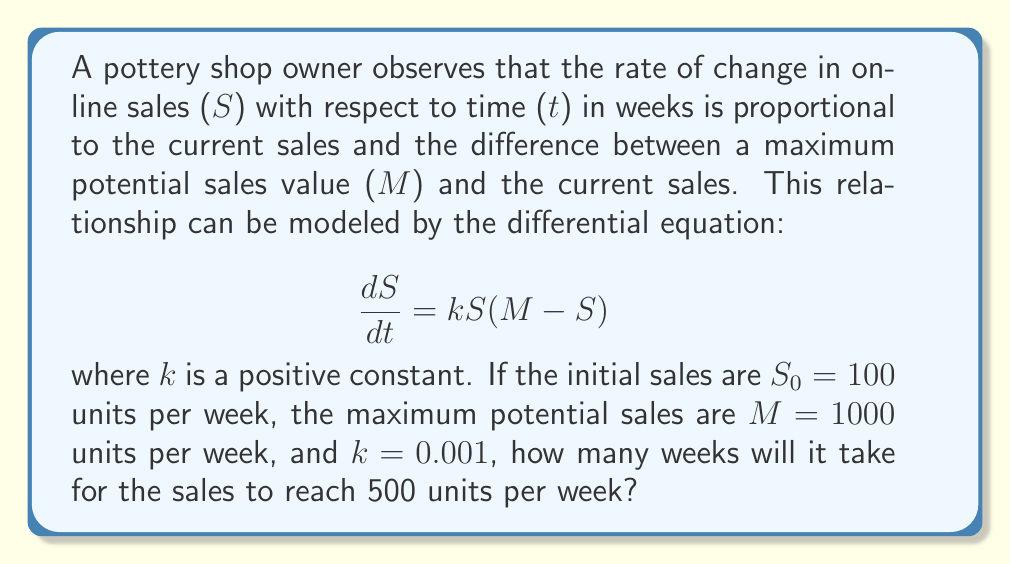Give your solution to this math problem. To solve this problem, we need to use the logistic growth model and its solution. The steps are as follows:

1) The given differential equation is a logistic growth model:

   $$\frac{dS}{dt} = kS(M-S)$$

2) The solution to this equation is:

   $$S(t) = \frac{M}{1 + (\frac{M}{S_0} - 1)e^{-kMt}}$$

3) We're given the following values:
   $S_0 = 100$, $M = 1000$, $k = 0.001$

4) We want to find t when $S(t) = 500$. Let's substitute these values into the equation:

   $$500 = \frac{1000}{1 + (\frac{1000}{100} - 1)e^{-0.001 \cdot 1000 \cdot t}}$$

5) Simplify:

   $$500 = \frac{1000}{1 + 9e^{-t}}$$

6) Multiply both sides by $(1 + 9e^{-t})$:

   $$500 + 4500e^{-t} = 1000$$

7) Subtract 500 from both sides:

   $$4500e^{-t} = 500$$

8) Divide both sides by 4500:

   $$e^{-t} = \frac{1}{9}$$

9) Take the natural log of both sides:

   $$-t = \ln(\frac{1}{9})$$

10) Solve for t:

    $$t = -\ln(\frac{1}{9}) = \ln(9) \approx 2.197$$

Therefore, it will take approximately 2.197 weeks for the sales to reach 500 units per week.
Answer: $\ln(9) \approx 2.197$ weeks 